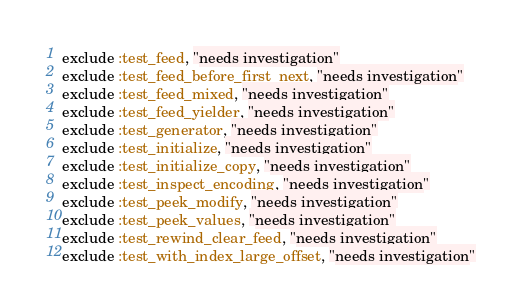<code> <loc_0><loc_0><loc_500><loc_500><_Ruby_>exclude :test_feed, "needs investigation"
exclude :test_feed_before_first_next, "needs investigation"
exclude :test_feed_mixed, "needs investigation"
exclude :test_feed_yielder, "needs investigation"
exclude :test_generator, "needs investigation"
exclude :test_initialize, "needs investigation"
exclude :test_initialize_copy, "needs investigation"
exclude :test_inspect_encoding, "needs investigation"
exclude :test_peek_modify, "needs investigation"
exclude :test_peek_values, "needs investigation"
exclude :test_rewind_clear_feed, "needs investigation"
exclude :test_with_index_large_offset, "needs investigation"
</code> 